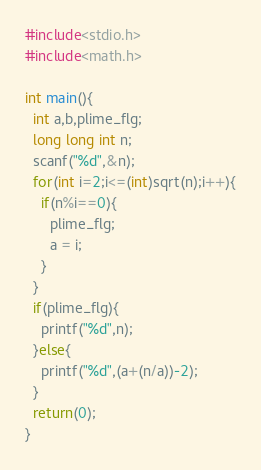<code> <loc_0><loc_0><loc_500><loc_500><_C_>#include<stdio.h>
#include<math.h>

int main(){
  int a,b,plime_flg;
  long long int n;
  scanf("%d",&n);
  for(int i=2;i<=(int)sqrt(n);i++){
    if(n%i==0){
      plime_flg;
      a = i;
    }
  }
  if(plime_flg){
    printf("%d",n);
  }else{
    printf("%d",(a+(n/a))-2);
  }
  return(0);
}</code> 